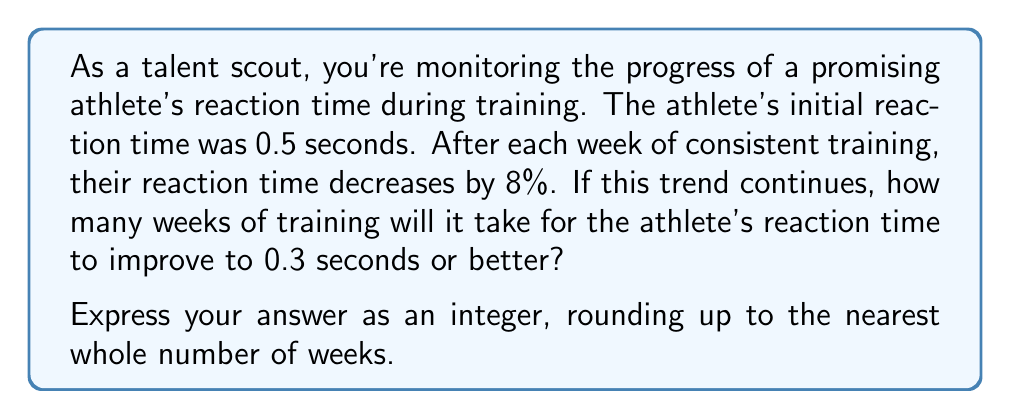Provide a solution to this math problem. Let's approach this step-by-step:

1) First, we need to set up an exponential decay equation. The general form is:

   $$A = A_0 \cdot (1-r)^t$$

   Where:
   $A$ is the final amount
   $A_0$ is the initial amount
   $r$ is the rate of decay (as a decimal)
   $t$ is the time (in this case, weeks)

2) We know:
   $A_0 = 0.5$ seconds (initial reaction time)
   $r = 0.08$ (8% decrease per week)
   $A = 0.3$ seconds (target reaction time)

3) Plugging these into our equation:

   $$0.3 = 0.5 \cdot (1-0.08)^t$$

4) Simplify:

   $$0.3 = 0.5 \cdot (0.92)^t$$

5) Divide both sides by 0.5:

   $$0.6 = (0.92)^t$$

6) Take the natural log of both sides:

   $$\ln(0.6) = t \cdot \ln(0.92)$$

7) Solve for $t$:

   $$t = \frac{\ln(0.6)}{\ln(0.92)} \approx 5.968$$

8) Since we need to round up to the nearest whole number of weeks, our final answer is 6 weeks.
Answer: 6 weeks 